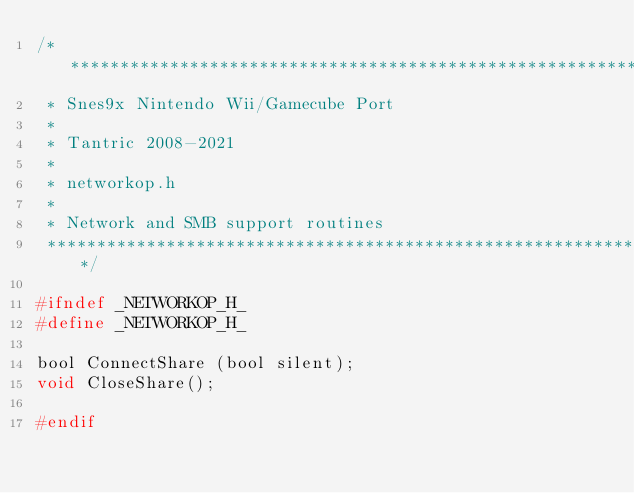Convert code to text. <code><loc_0><loc_0><loc_500><loc_500><_C_>/****************************************************************************
 * Snes9x Nintendo Wii/Gamecube Port
 *
 * Tantric 2008-2021
 *
 * networkop.h
 *
 * Network and SMB support routines
 ****************************************************************************/

#ifndef _NETWORKOP_H_
#define _NETWORKOP_H_

bool ConnectShare (bool silent);
void CloseShare();

#endif
</code> 